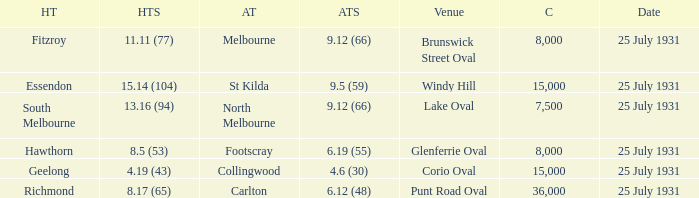Can you give me this table as a dict? {'header': ['HT', 'HTS', 'AT', 'ATS', 'Venue', 'C', 'Date'], 'rows': [['Fitzroy', '11.11 (77)', 'Melbourne', '9.12 (66)', 'Brunswick Street Oval', '8,000', '25 July 1931'], ['Essendon', '15.14 (104)', 'St Kilda', '9.5 (59)', 'Windy Hill', '15,000', '25 July 1931'], ['South Melbourne', '13.16 (94)', 'North Melbourne', '9.12 (66)', 'Lake Oval', '7,500', '25 July 1931'], ['Hawthorn', '8.5 (53)', 'Footscray', '6.19 (55)', 'Glenferrie Oval', '8,000', '25 July 1931'], ['Geelong', '4.19 (43)', 'Collingwood', '4.6 (30)', 'Corio Oval', '15,000', '25 July 1931'], ['Richmond', '8.17 (65)', 'Carlton', '6.12 (48)', 'Punt Road Oval', '36,000', '25 July 1931']]} When the home team was fitzroy, what did the away team score? 9.12 (66). 